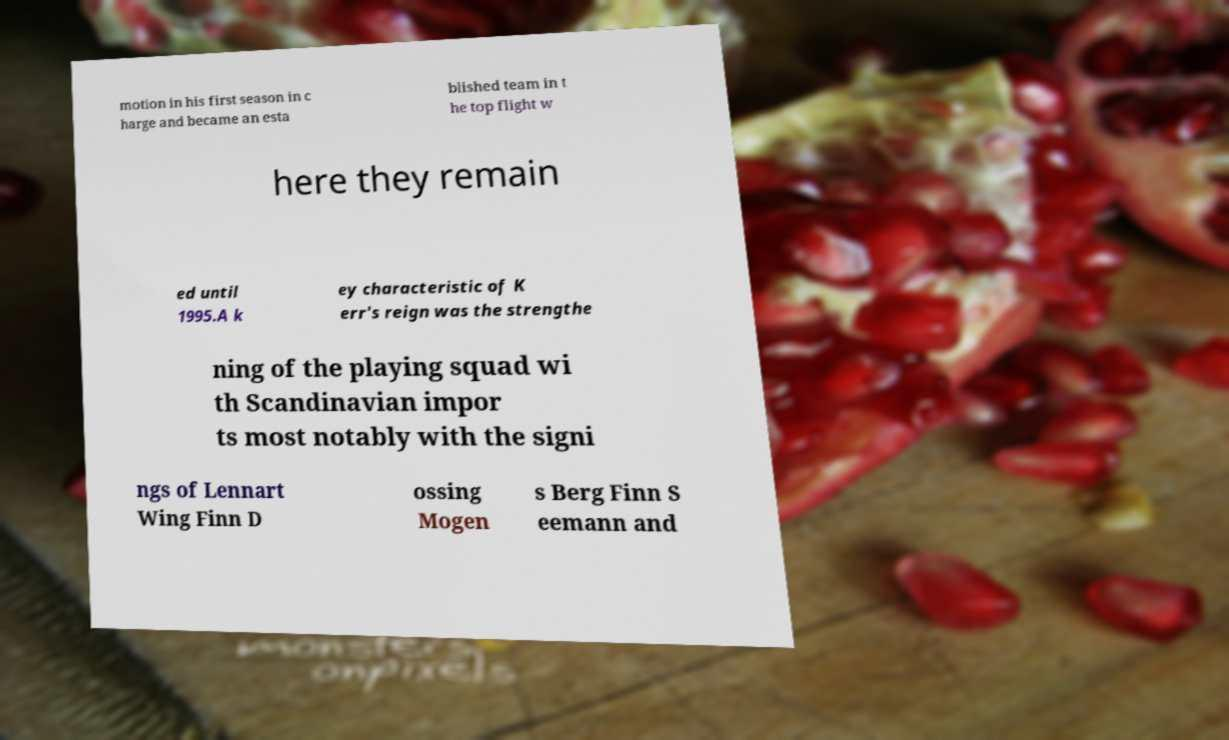What messages or text are displayed in this image? I need them in a readable, typed format. motion in his first season in c harge and became an esta blished team in t he top flight w here they remain ed until 1995.A k ey characteristic of K err's reign was the strengthe ning of the playing squad wi th Scandinavian impor ts most notably with the signi ngs of Lennart Wing Finn D ossing Mogen s Berg Finn S eemann and 